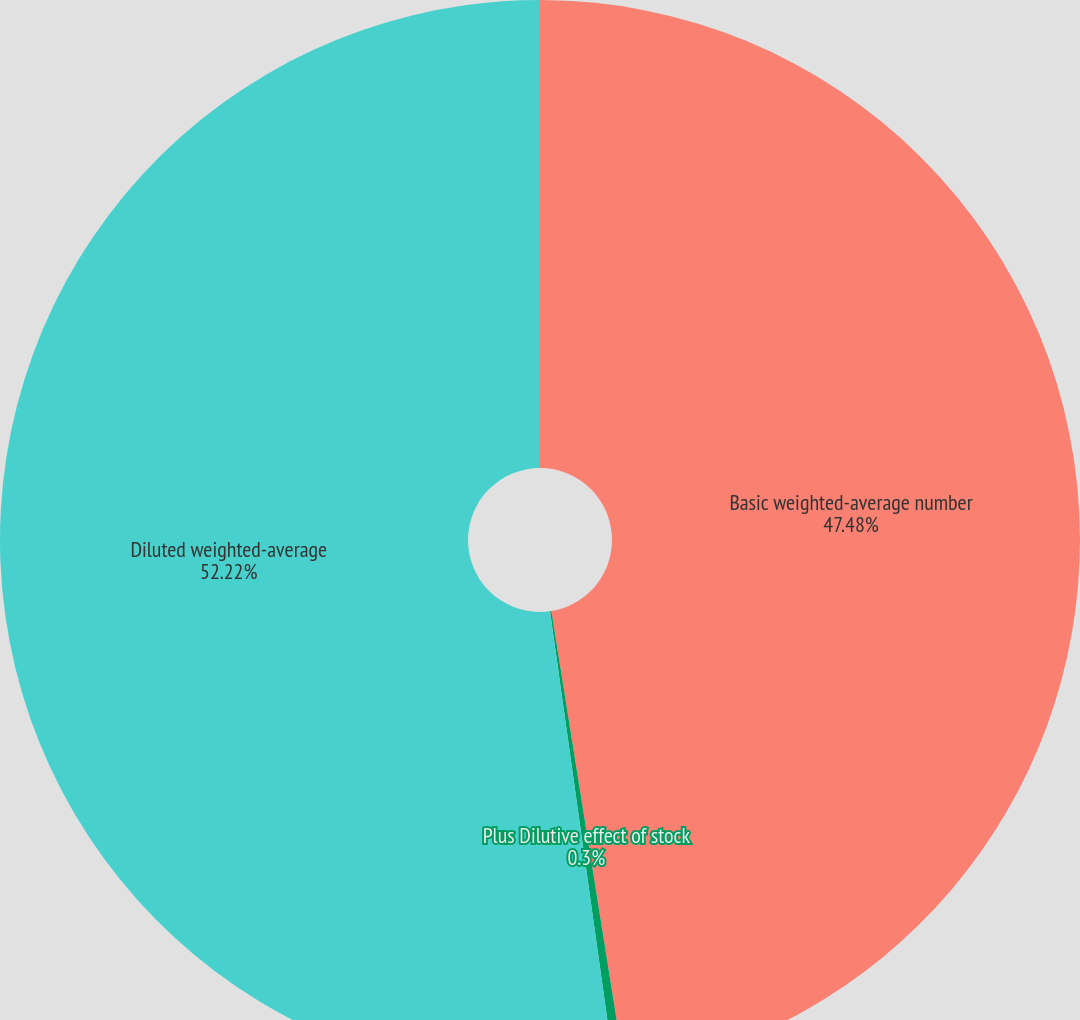Convert chart. <chart><loc_0><loc_0><loc_500><loc_500><pie_chart><fcel>Basic weighted-average number<fcel>Plus Dilutive effect of stock<fcel>Diluted weighted-average<nl><fcel>47.48%<fcel>0.3%<fcel>52.22%<nl></chart> 